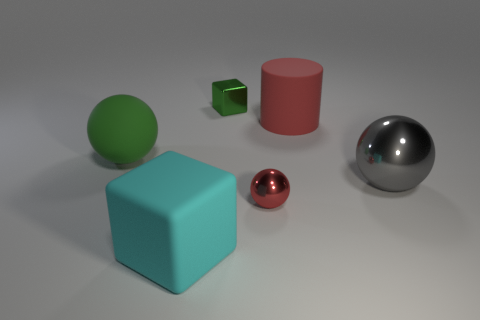Is there a big red object?
Give a very brief answer. Yes. There is a small red thing that is the same shape as the large green rubber object; what material is it?
Your answer should be compact. Metal. There is a small object behind the rubber thing that is right of the cube to the right of the big cyan block; what is its shape?
Provide a short and direct response. Cube. There is a sphere that is the same color as the small metallic cube; what is its material?
Your response must be concise. Rubber. How many small green metal things are the same shape as the large gray metallic object?
Make the answer very short. 0. Does the ball that is behind the large gray metal thing have the same color as the metallic ball in front of the gray metallic thing?
Offer a very short reply. No. There is a green ball that is the same size as the cyan matte thing; what is it made of?
Provide a succinct answer. Rubber. Are there any green metallic objects that have the same size as the gray object?
Provide a short and direct response. No. Are there fewer big green rubber objects to the right of the large red cylinder than green matte blocks?
Provide a short and direct response. No. Are there fewer big red rubber things that are in front of the large green matte ball than large gray metal spheres that are left of the big block?
Your response must be concise. No. 